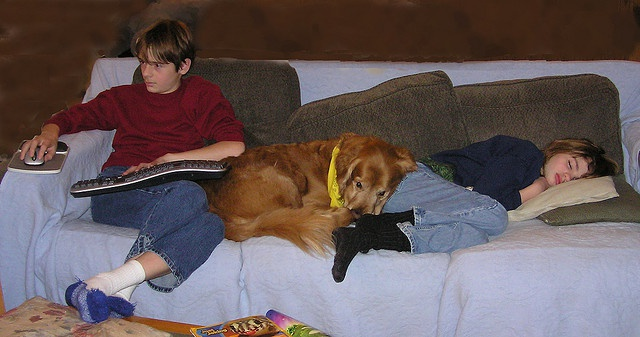Describe the objects in this image and their specific colors. I can see couch in maroon, darkgray, and black tones, people in maroon, black, navy, and gray tones, people in maroon, black, and gray tones, dog in maroon, brown, and gray tones, and keyboard in maroon, black, gray, and darkgray tones in this image. 